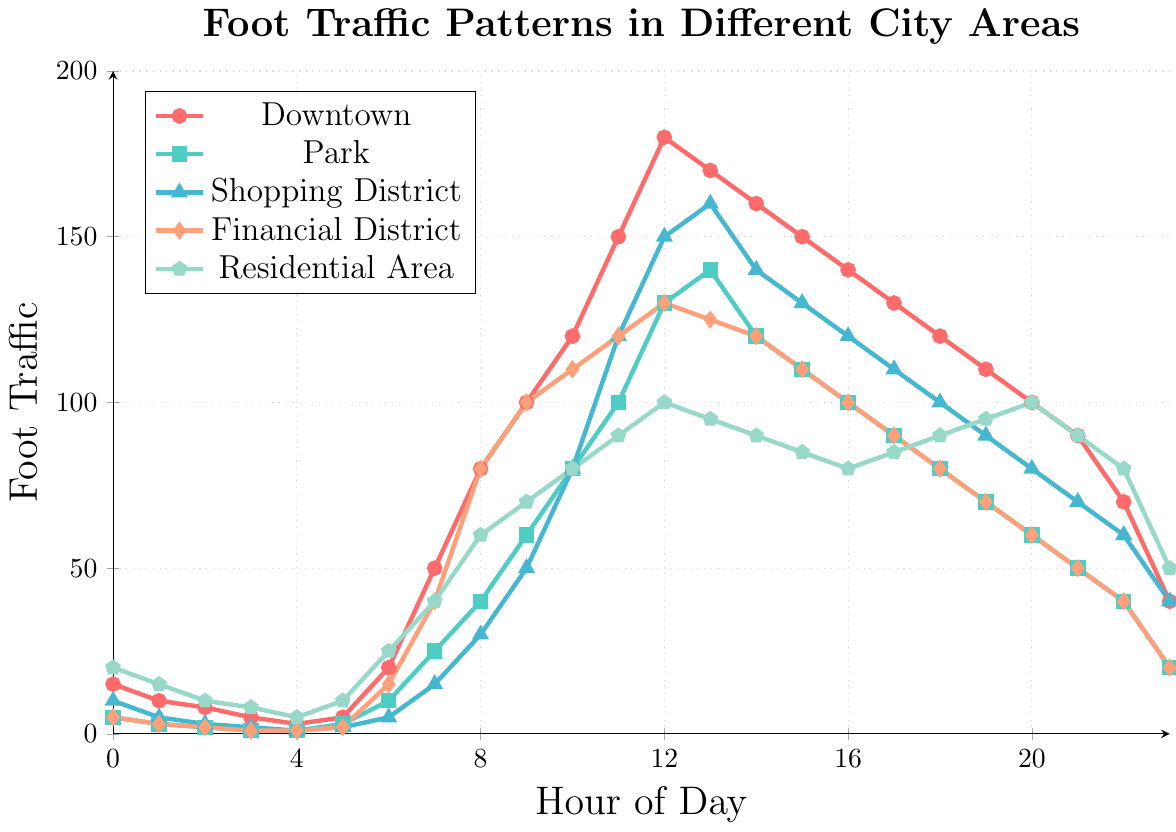What is the peak foot traffic hour for Downtown? According to the plot, the highest point in the Downtown line occurs at Hour 12, where the foot traffic reaches 180.
Answer: Hour 12 How does foot traffic in the Residential Area at 6 AM compare to that in the Financial District at the same time? At 6 AM (Hour 6), the plot shows the foot traffic in the Residential Area as 25 and in the Financial District as 15. Thus, the Residential Area has higher foot traffic.
Answer: Residential Area Which area has the lowest overall foot traffic at midnight? At 12 AM (Hour 0), the plot shows foot traffic values for Downtown (15), Park (5), Shopping District (10), Financial District (5), and Residential Area (20). The Park and Financial District both have the lowest foot traffic of 5.
Answer: Park and Financial District What is the difference in foot traffic between Park and Shopping District at noon? At 12 PM (Hour 12), the plot shows foot traffic for the Park as 130 and for the Shopping District as 150. The difference is 150 - 130 = 20.
Answer: 20 During which hours does the Financial District have its peak foot traffic? The plot displays the highest foot traffic for the Financial District at Hour 12, where it reaches 130.
Answer: Hour 12 How has foot traffic in the Shopping District changed from 10 AM to 2 PM? At 10 AM (Hour 10), the Shopping District has a foot traffic value of 80. At 2 PM (Hour 14), it is 140. The traffic increased by 140 - 80 = 60.
Answer: Increased by 60 What is the average foot traffic in the Residential Area from 9 AM to 11 AM? The foot traffic values in the Residential Area for 9 AM (Hour 9), 10 AM (Hour 10), and 11 AM (Hour 11) are 70, 80, and 90, respectively. The average is (70 + 80 + 90) / 3 = 240 / 3 = 80.
Answer: 80 At what times of day does foot traffic in the Park exceed 100? The plot shows that foot traffic in the Park exceeds 100 during Hour 11 (100), Hour 12 (130), and Hour 13 (140).
Answer: 11 AM, 12 PM, 1 PM Which area has the greatest foot traffic at 8 PM? At 8 PM (Hour 20), the plot shows foot traffic values as Downtown (100), Park (60), Shopping District (80), Financial District (60), and Residential Area (100). Downtown and Residential Area both have the greatest foot traffic of 100.
Answer: Downtown and Residential Area 